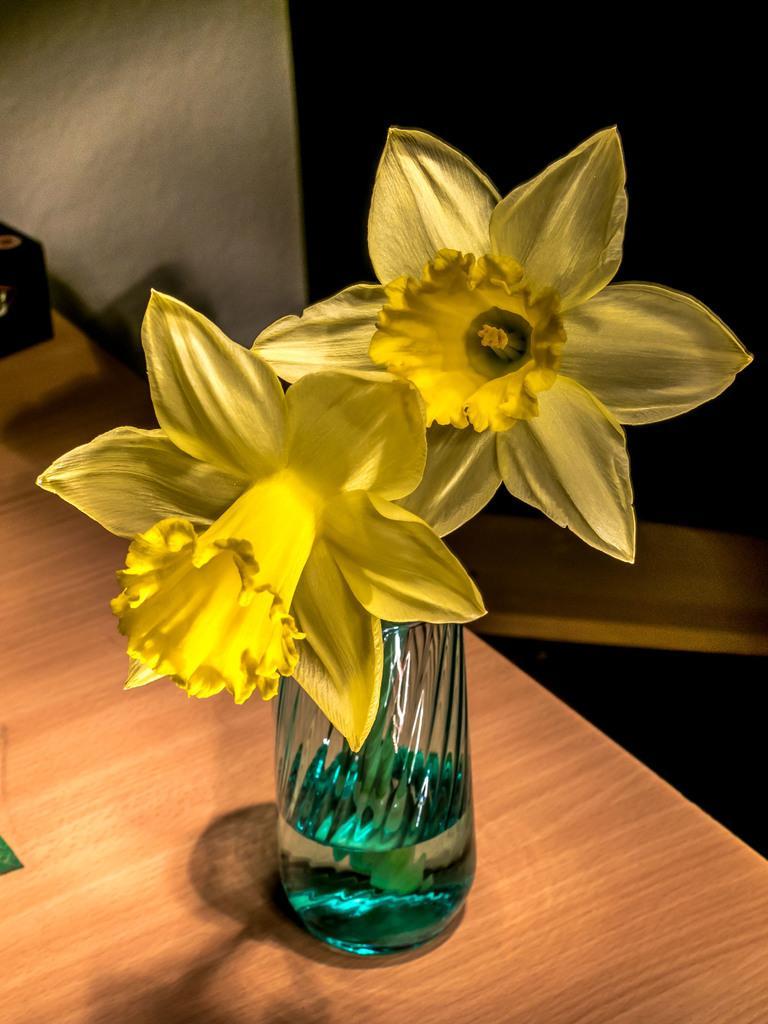In one or two sentences, can you explain what this image depicts? In the center of the image there is a table. On the table we can see a glass. In glass flowers are there. In the background of the image wall is present. 